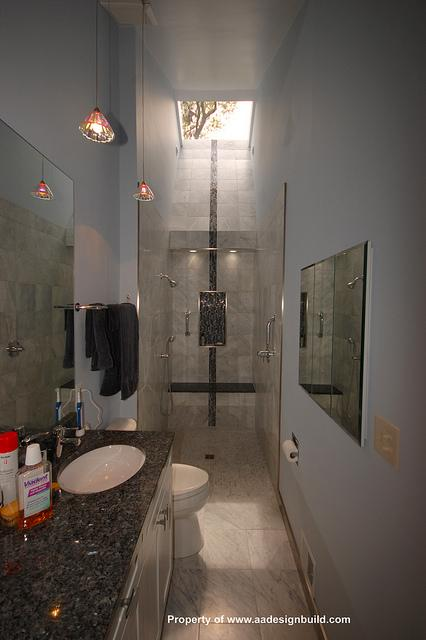What is the item with the white cap used to clean? Please explain your reasoning. mouth. It appears to be this based on the shape of the bottle, the color of the liquid and its location near th esink. the other options also don't fit. 